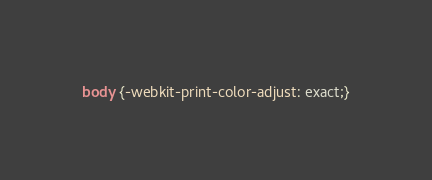<code> <loc_0><loc_0><loc_500><loc_500><_CSS_>body {-webkit-print-color-adjust: exact;}</code> 